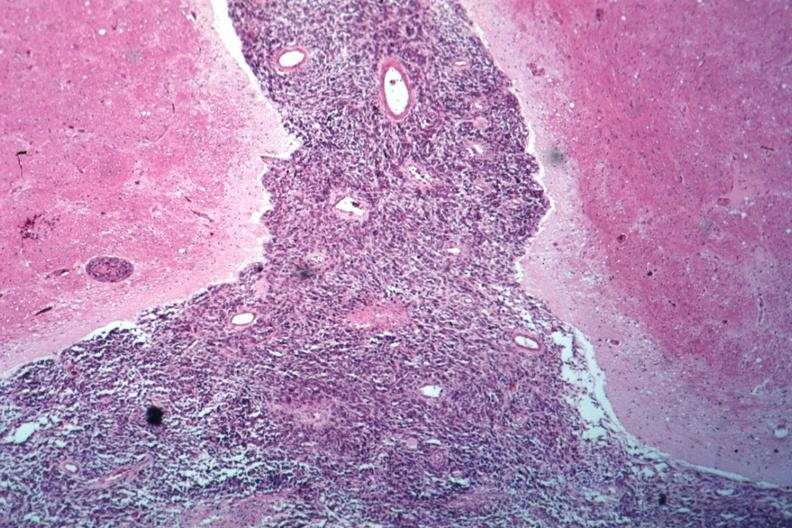what is present?
Answer the question using a single word or phrase. Carcinomatous meningitis 